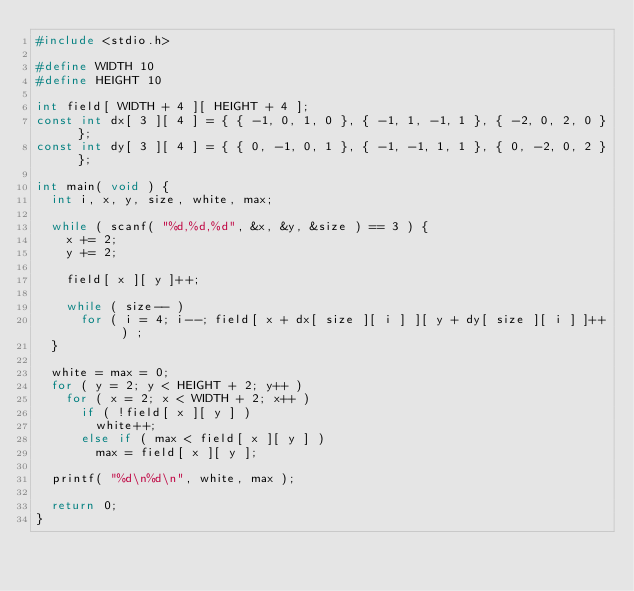Convert code to text. <code><loc_0><loc_0><loc_500><loc_500><_C_>#include <stdio.h>

#define WIDTH 10
#define HEIGHT 10

int field[ WIDTH + 4 ][ HEIGHT + 4 ];
const int dx[ 3 ][ 4 ] = { { -1, 0, 1, 0 }, { -1, 1, -1, 1 }, { -2, 0, 2, 0 } };
const int dy[ 3 ][ 4 ] = { { 0, -1, 0, 1 }, { -1, -1, 1, 1 }, { 0, -2, 0, 2 } };

int main( void ) {
	int i, x, y, size, white, max;

	while ( scanf( "%d,%d,%d", &x, &y, &size ) == 3 ) {
		x += 2;
		y += 2;

		field[ x ][ y ]++;

		while ( size-- )
			for ( i = 4; i--; field[ x + dx[ size ][ i ] ][ y + dy[ size ][ i ] ]++ ) ;				
	}

	white = max = 0;
	for ( y = 2; y < HEIGHT + 2; y++ )
		for ( x = 2; x < WIDTH + 2; x++ )
			if ( !field[ x ][ y ] )
				white++;
			else if ( max < field[ x ][ y ] )
				max = field[ x ][ y ];

	printf( "%d\n%d\n", white, max );

	return 0;
}</code> 